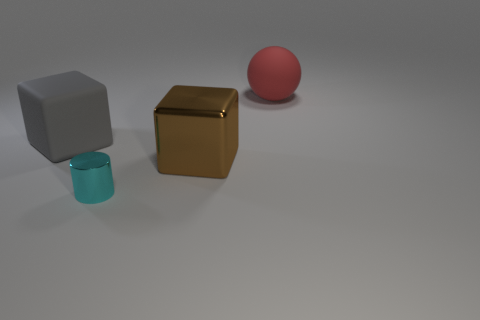There is a object that is both behind the brown shiny object and to the right of the gray object; what is its size?
Your answer should be very brief. Large. There is a tiny cyan cylinder to the right of the big rubber block; what is it made of?
Give a very brief answer. Metal. Do the large rubber sphere and the block behind the big metal block have the same color?
Make the answer very short. No. How many things are either big matte things that are in front of the red rubber object or large cubes that are behind the metal cube?
Offer a terse response. 1. What is the color of the thing that is both on the right side of the shiny cylinder and in front of the large gray matte cube?
Provide a succinct answer. Brown. Is the number of red matte spheres greater than the number of yellow matte cubes?
Give a very brief answer. Yes. There is a large object in front of the large rubber block; does it have the same shape as the red object?
Your response must be concise. No. What number of metallic objects are either large gray objects or cylinders?
Offer a terse response. 1. Are there any small red cubes that have the same material as the cyan cylinder?
Make the answer very short. No. What is the material of the brown cube?
Your response must be concise. Metal. 